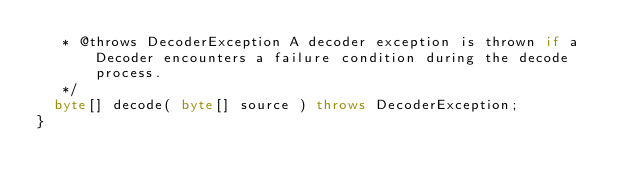Convert code to text. <code><loc_0><loc_0><loc_500><loc_500><_Java_>   * @throws DecoderException A decoder exception is thrown if a Decoder encounters a failure condition during the decode process.
   */
  byte[] decode( byte[] source ) throws DecoderException;
}
</code> 